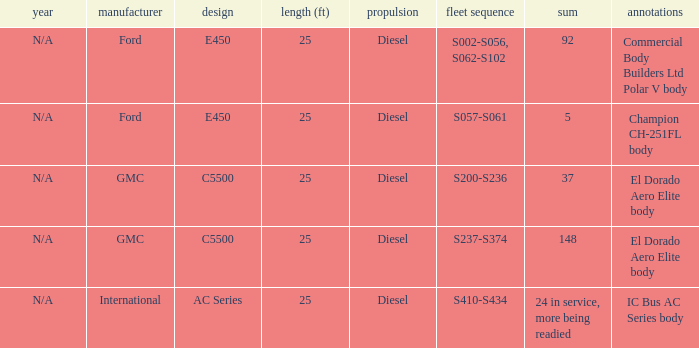Parse the full table. {'header': ['year', 'manufacturer', 'design', 'length (ft)', 'propulsion', 'fleet sequence', 'sum', 'annotations'], 'rows': [['N/A', 'Ford', 'E450', '25', 'Diesel', 'S002-S056, S062-S102', '92', 'Commercial Body Builders Ltd Polar V body'], ['N/A', 'Ford', 'E450', '25', 'Diesel', 'S057-S061', '5', 'Champion CH-251FL body'], ['N/A', 'GMC', 'C5500', '25', 'Diesel', 'S200-S236', '37', 'El Dorado Aero Elite body'], ['N/A', 'GMC', 'C5500', '25', 'Diesel', 'S237-S374', '148', 'El Dorado Aero Elite body'], ['N/A', 'International', 'AC Series', '25', 'Diesel', 'S410-S434', '24 in service, more being readied', 'IC Bus AC Series body']]} How many international builders are there? 24 in service, more being readied. 